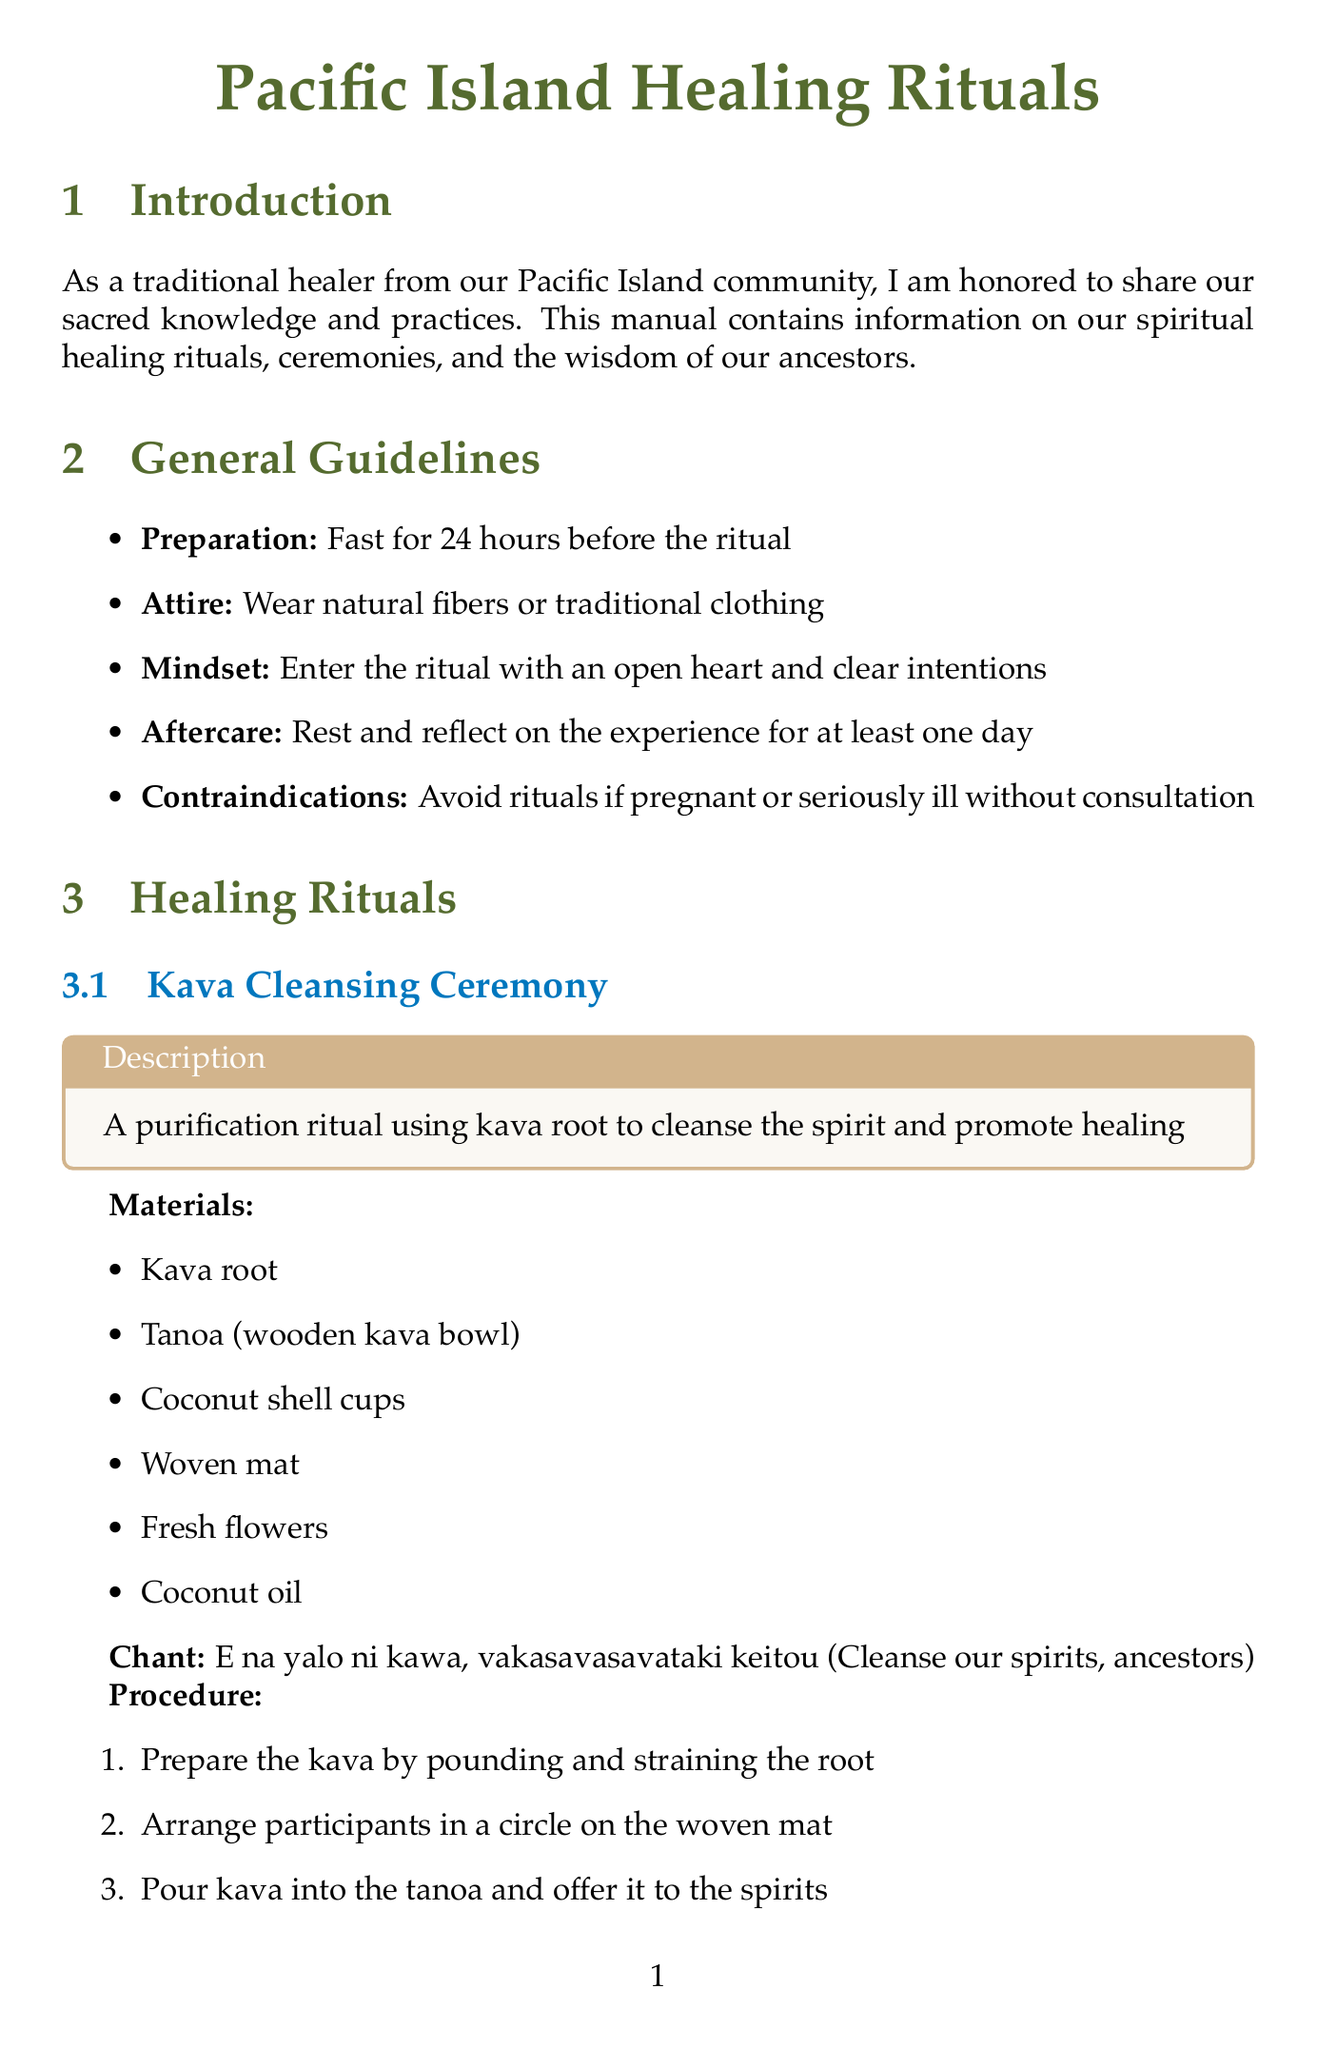what is the first ritual listed in the document? The first ritual mentioned in the document is the "Kava Cleansing Ceremony."
Answer: Kava Cleansing Ceremony how many materials are required for the Tī Leaf Protection Ritual? The Tī Leaf Protection Ritual requires six materials listed in the document.
Answer: 6 what chant is used in the Ocean Healing Immersion? The chant used in the Ocean Healing Immersion is written in the document.
Answer: Moana e, fa'amalolo mai i o matou tino ma agaga what is the primary use of Noni? The document states that Noni is used for immune support, pain relief, and spiritual purification.
Answer: Immune support, pain relief, spiritual purification what should participants wear during the rituals? The guidelines suggest wearing natural fibers or traditional clothing during the rituals.
Answer: Natural fibers or traditional clothing how long should one rest after the ritual? According to the aftercare instructions in the document, individuals should rest for at least one day after the ritual.
Answer: At least one day what symbol represents longevity and peace? The document highlights the honu symbol as representing longevity and peace.
Answer: Honu how many sacred plants are mentioned in the document? The document states that there are three sacred plants included in the descriptions.
Answer: 3 